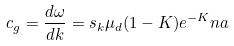Convert formula to latex. <formula><loc_0><loc_0><loc_500><loc_500>c _ { g } = \frac { d \omega } { d k } = s _ { k } \mu _ { d } ( 1 - K ) e ^ { - K } n a</formula> 